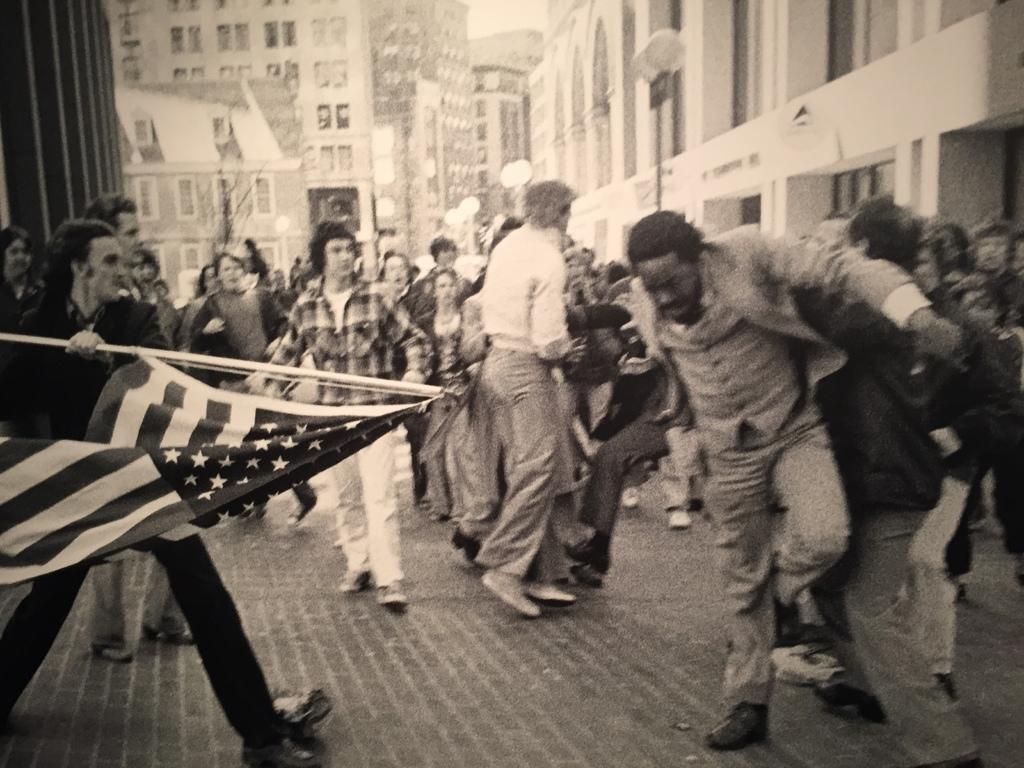Describe this image in one or two sentences. In this image we can see a black and white image. In this image there are some persons, flag and other objects. In the background of the image there are buildings, lights and other objects. At the bottom of the image there is a floor. 